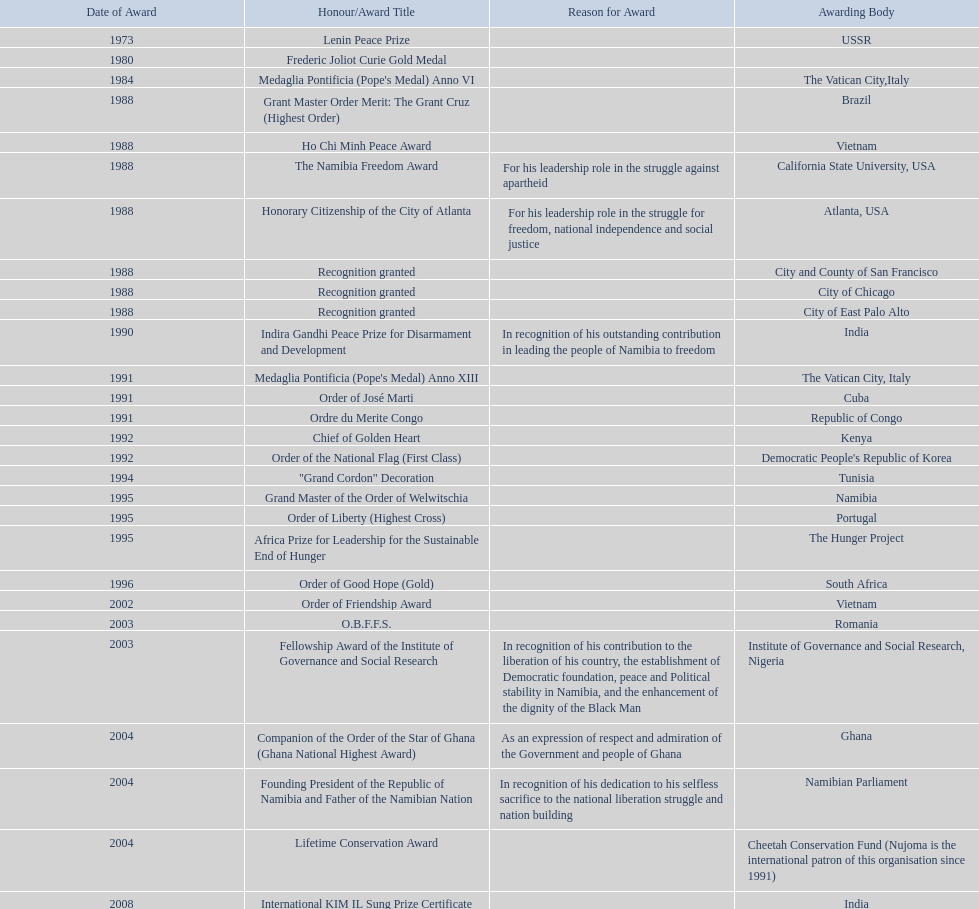Parse the table in full. {'header': ['Date of Award', 'Honour/Award Title', 'Reason for Award', 'Awarding Body'], 'rows': [['1973', 'Lenin Peace Prize', '', 'USSR'], ['1980', 'Frederic Joliot Curie Gold Medal', '', ''], ['1984', "Medaglia Pontificia (Pope's Medal) Anno VI", '', 'The Vatican City,Italy'], ['1988', 'Grant Master Order Merit: The Grant Cruz (Highest Order)', '', 'Brazil'], ['1988', 'Ho Chi Minh Peace Award', '', 'Vietnam'], ['1988', 'The Namibia Freedom Award', 'For his leadership role in the struggle against apartheid', 'California State University, USA'], ['1988', 'Honorary Citizenship of the City of Atlanta', 'For his leadership role in the struggle for freedom, national independence and social justice', 'Atlanta, USA'], ['1988', 'Recognition granted', '', 'City and County of San Francisco'], ['1988', 'Recognition granted', '', 'City of Chicago'], ['1988', 'Recognition granted', '', 'City of East Palo Alto'], ['1990', 'Indira Gandhi Peace Prize for Disarmament and Development', 'In recognition of his outstanding contribution in leading the people of Namibia to freedom', 'India'], ['1991', "Medaglia Pontificia (Pope's Medal) Anno XIII", '', 'The Vatican City, Italy'], ['1991', 'Order of José Marti', '', 'Cuba'], ['1991', 'Ordre du Merite Congo', '', 'Republic of Congo'], ['1992', 'Chief of Golden Heart', '', 'Kenya'], ['1992', 'Order of the National Flag (First Class)', '', "Democratic People's Republic of Korea"], ['1994', '"Grand Cordon" Decoration', '', 'Tunisia'], ['1995', 'Grand Master of the Order of Welwitschia', '', 'Namibia'], ['1995', 'Order of Liberty (Highest Cross)', '', 'Portugal'], ['1995', 'Africa Prize for Leadership for the Sustainable End of Hunger', '', 'The Hunger Project'], ['1996', 'Order of Good Hope (Gold)', '', 'South Africa'], ['2002', 'Order of Friendship Award', '', 'Vietnam'], ['2003', 'O.B.F.F.S.', '', 'Romania'], ['2003', 'Fellowship Award of the Institute of Governance and Social Research', 'In recognition of his contribution to the liberation of his country, the establishment of Democratic foundation, peace and Political stability in Namibia, and the enhancement of the dignity of the Black Man', 'Institute of Governance and Social Research, Nigeria'], ['2004', 'Companion of the Order of the Star of Ghana (Ghana National Highest Award)', 'As an expression of respect and admiration of the Government and people of Ghana', 'Ghana'], ['2004', 'Founding President of the Republic of Namibia and Father of the Namibian Nation', 'In recognition of his dedication to his selfless sacrifice to the national liberation struggle and nation building', 'Namibian Parliament'], ['2004', 'Lifetime Conservation Award', '', 'Cheetah Conservation Fund (Nujoma is the international patron of this organisation since 1991)'], ['2008', 'International KIM IL Sung Prize Certificate', '', 'India'], ['2010', 'Sir Seretse Khama SADC Meda', '', 'SADC']]} What is the difference between the number of awards won in 1988 and the number of awards won in 1995? 4. 